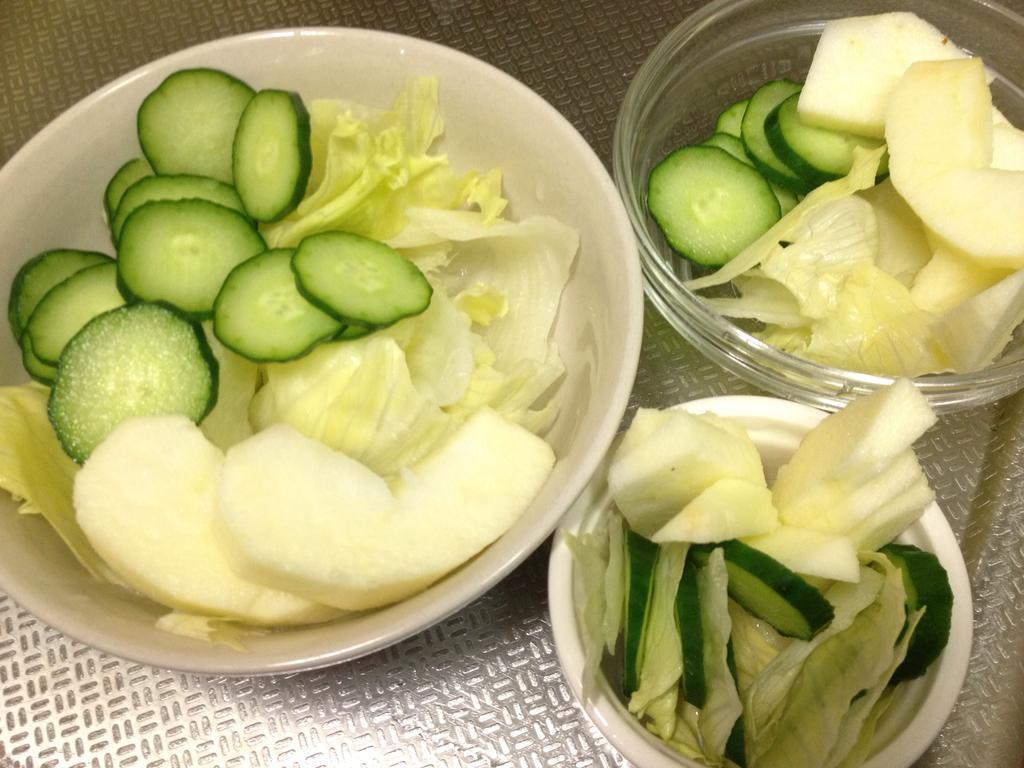Please provide a concise description of this image. In this image I can see there are food items in the bowls. 